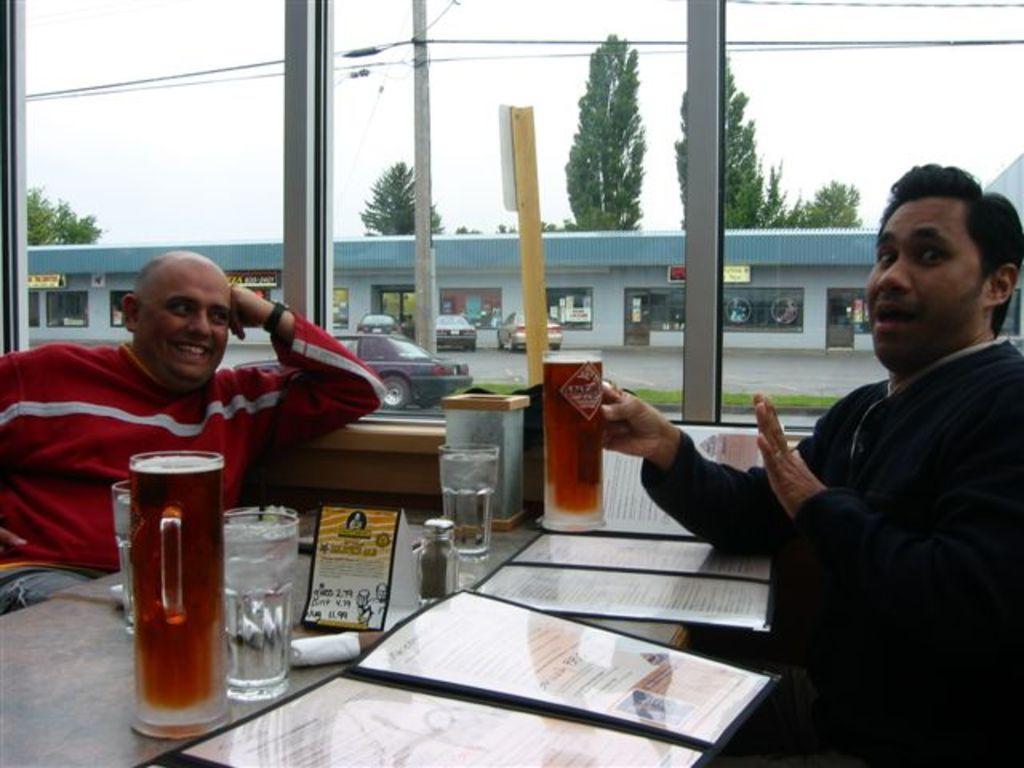Describe this image in one or two sentences. In this picture we can see two men sitting and smiling and holding glass in his hand and in front of them there is table and on table we can see files, cards, glasses, bottle and from glass we can see building, cars on road, trees, sky, pole, wires. 